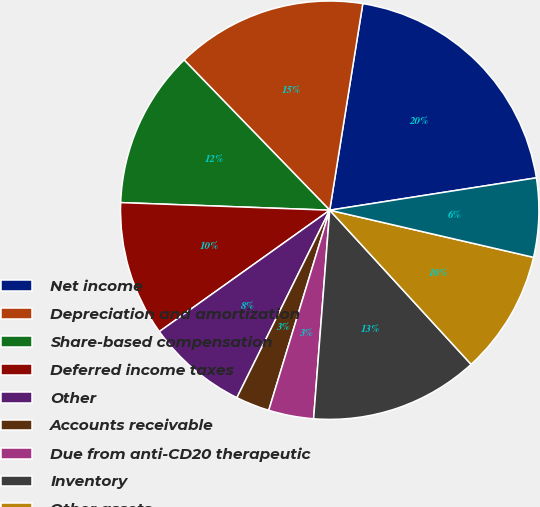Convert chart. <chart><loc_0><loc_0><loc_500><loc_500><pie_chart><fcel>Net income<fcel>Depreciation and amortization<fcel>Share-based compensation<fcel>Deferred income taxes<fcel>Other<fcel>Accounts receivable<fcel>Due from anti-CD20 therapeutic<fcel>Inventory<fcel>Other assets<fcel>Accrued expenses and other<nl><fcel>20.0%<fcel>14.78%<fcel>12.17%<fcel>10.43%<fcel>7.83%<fcel>2.61%<fcel>3.48%<fcel>13.04%<fcel>9.57%<fcel>6.09%<nl></chart> 